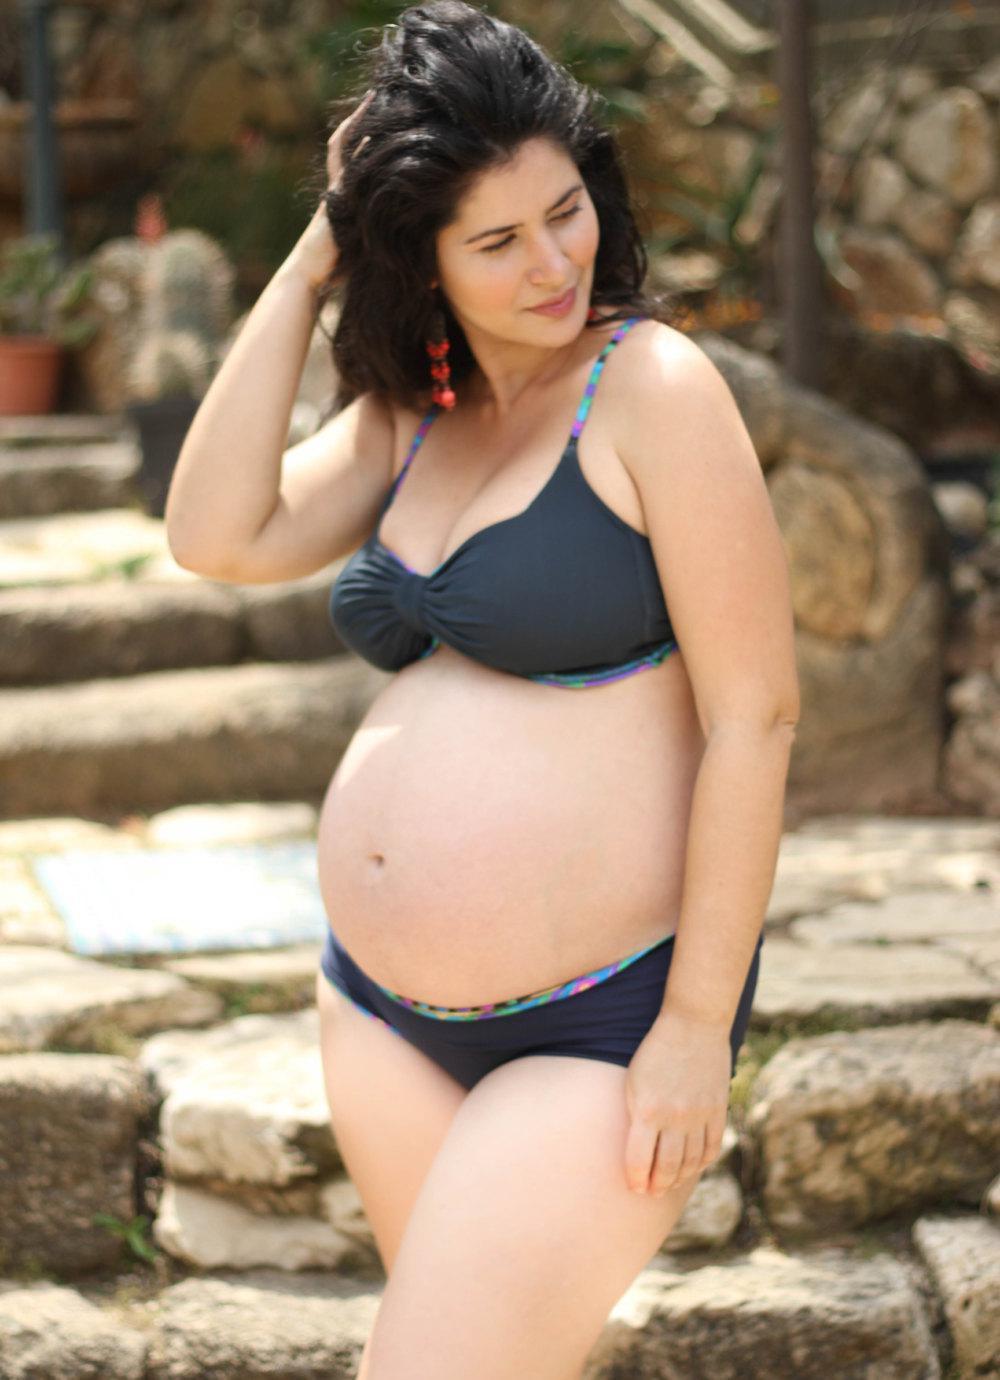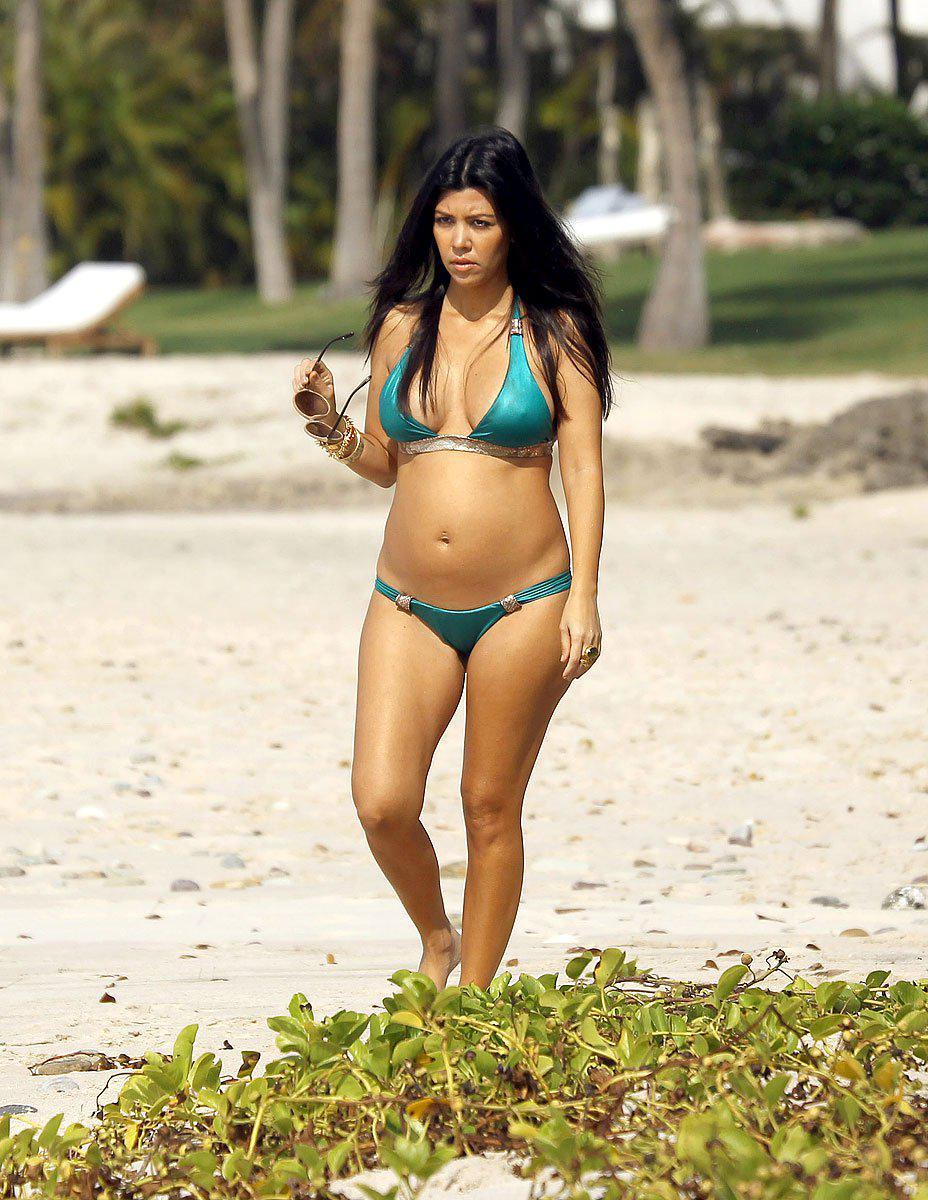The first image is the image on the left, the second image is the image on the right. Assess this claim about the two images: "There is a woman with at least one of her hands touching her hair.". Correct or not? Answer yes or no. Yes. The first image is the image on the left, the second image is the image on the right. Assess this claim about the two images: "The woman in the image on the right is wearing a white bikini.". Correct or not? Answer yes or no. No. 